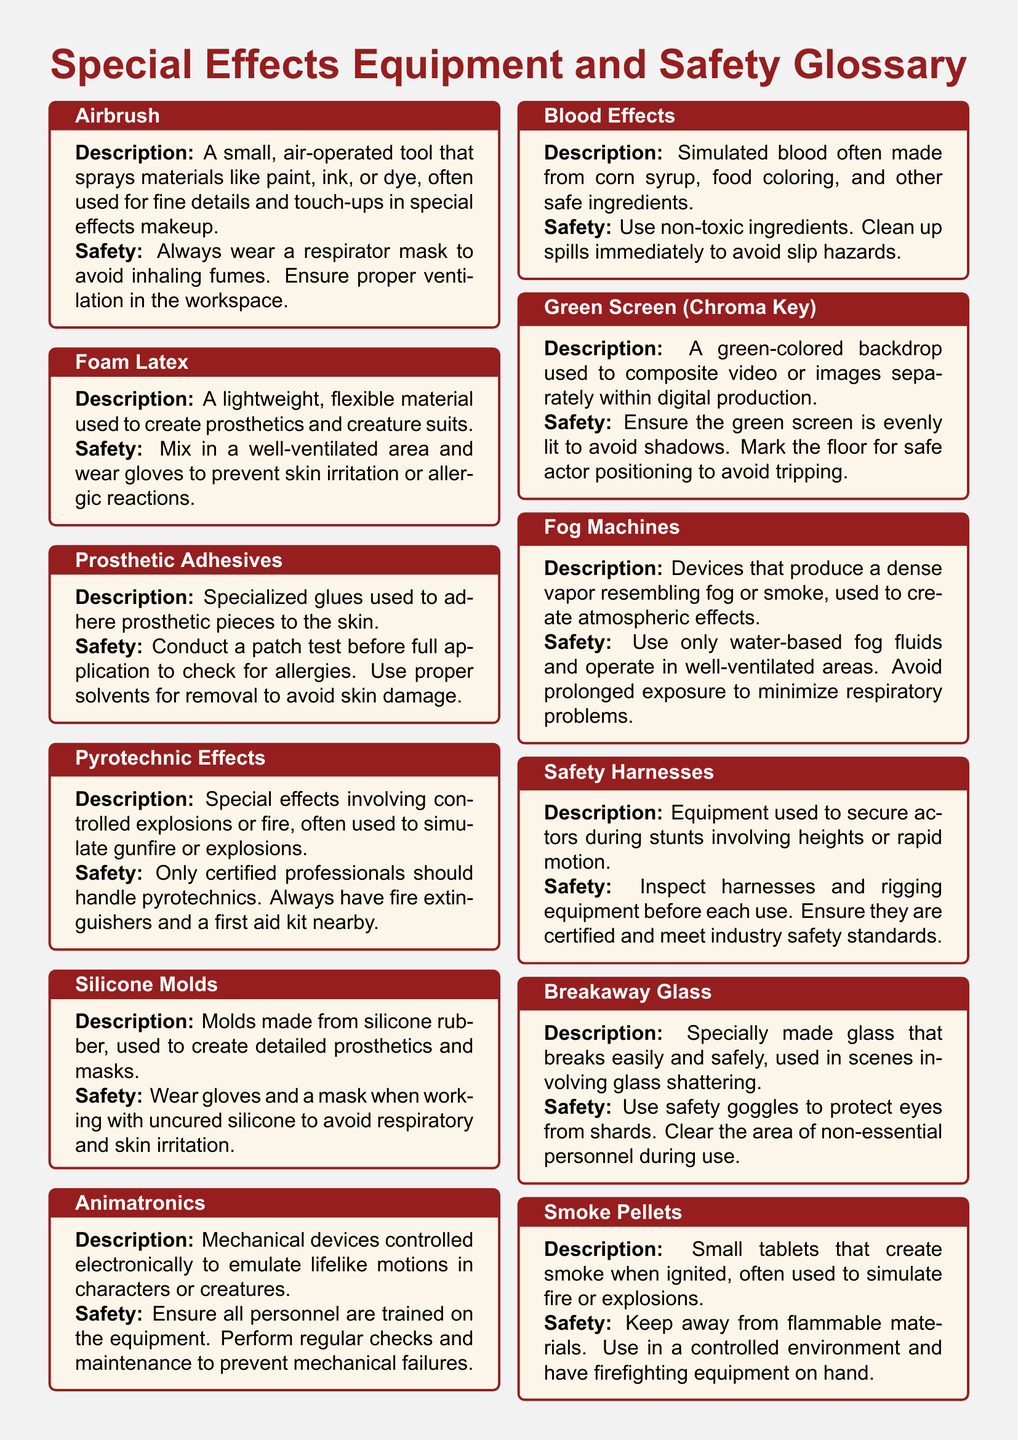What is the primary use of an airbrush? The primary use of an airbrush is to spray materials like paint, ink, or dye for fine details and touch-ups in special effects makeup.
Answer: Fine details and touch-ups in special effects makeup What personal protective equipment is recommended when using foam latex? The recommended personal protective equipment when using foam latex is gloves to prevent skin irritation or allergic reactions.
Answer: Gloves Who should handle pyrotechnic effects? Only certified professionals should handle pyrotechnic effects.
Answer: Certified professionals What should be ensured when working with silicone molds? When working with silicone molds, it is important to wear gloves and a mask to avoid respiratory and skin irritation.
Answer: Wear gloves and a mask What is the main ingredient used to create simulated blood effects? The main ingredient used to create simulated blood effects is corn syrup.
Answer: Corn syrup How should breakaway glass be used safely? Breakaway glass should be used safely by wearing safety goggles and clearing the area of non-essential personnel during use.
Answer: Wear safety goggles and clear the area What type of effects do fog machines produce? Fog machines produce a dense vapor resembling fog or smoke, used to create atmospheric effects.
Answer: Dense vapor resembling fog or smoke What safety precaution should be taken with smoke pellets? A safety precaution with smoke pellets is to keep them away from flammable materials.
Answer: Keep away from flammable materials What equipment is used to secure actors during stunts involving heights? The equipment used to secure actors during stunts involving heights is safety harnesses.
Answer: Safety harnesses 